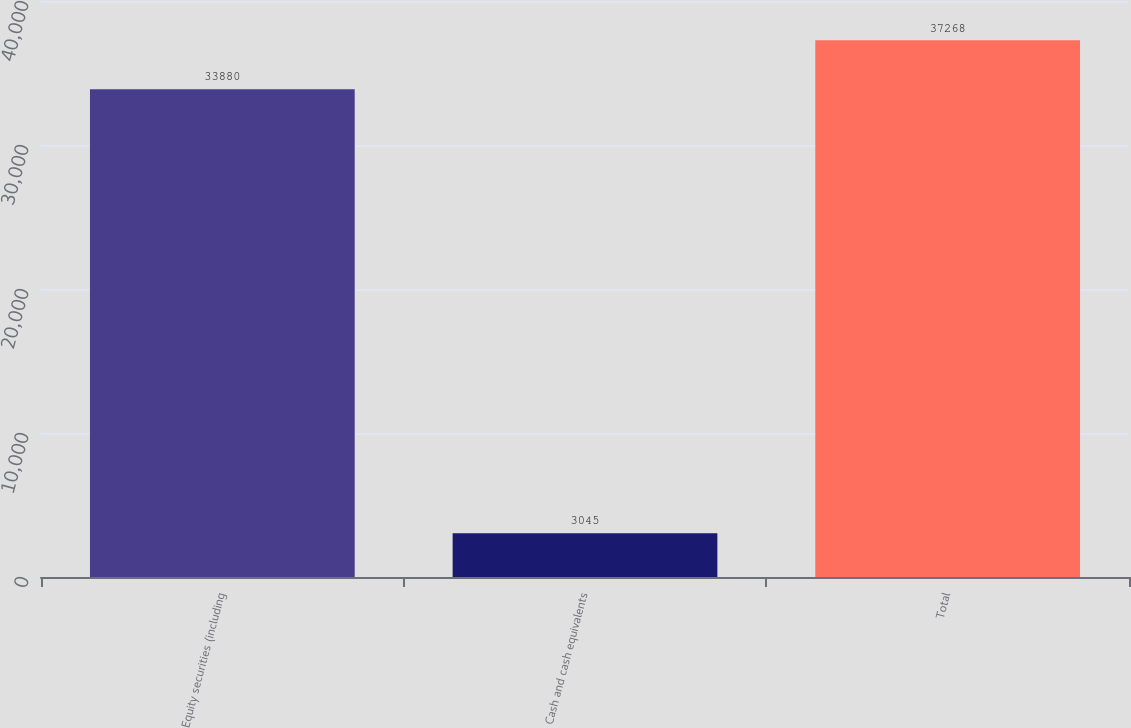Convert chart to OTSL. <chart><loc_0><loc_0><loc_500><loc_500><bar_chart><fcel>Equity securities (including<fcel>Cash and cash equivalents<fcel>Total<nl><fcel>33880<fcel>3045<fcel>37268<nl></chart> 